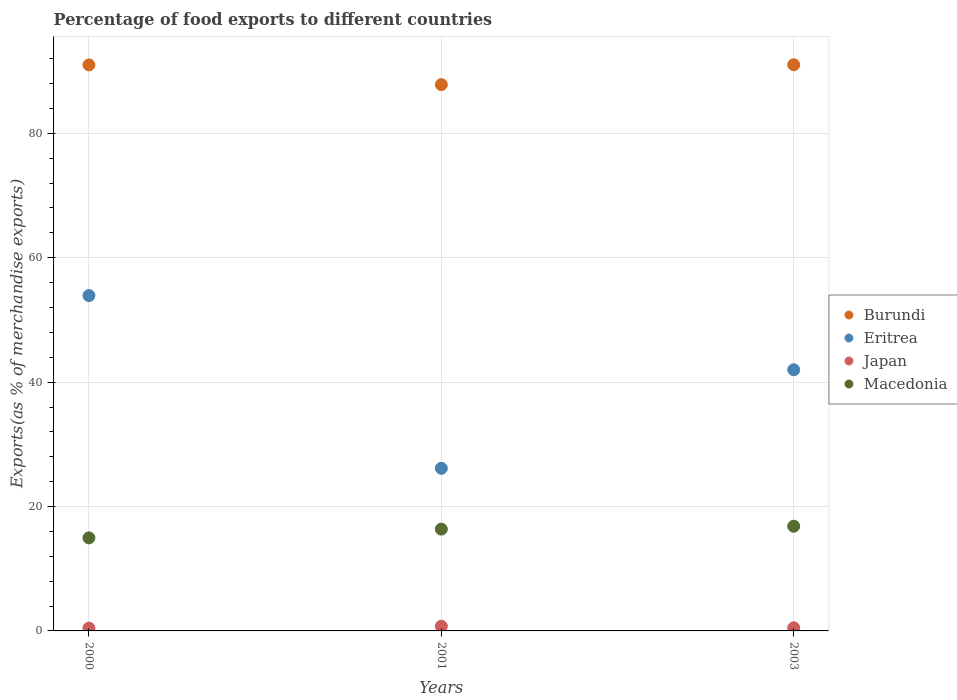What is the percentage of exports to different countries in Burundi in 2001?
Ensure brevity in your answer.  87.83. Across all years, what is the maximum percentage of exports to different countries in Burundi?
Give a very brief answer. 91.03. Across all years, what is the minimum percentage of exports to different countries in Japan?
Provide a succinct answer. 0.45. In which year was the percentage of exports to different countries in Burundi maximum?
Your answer should be very brief. 2003. What is the total percentage of exports to different countries in Macedonia in the graph?
Keep it short and to the point. 48.16. What is the difference between the percentage of exports to different countries in Japan in 2000 and that in 2003?
Keep it short and to the point. -0.05. What is the difference between the percentage of exports to different countries in Burundi in 2001 and the percentage of exports to different countries in Macedonia in 2000?
Offer a terse response. 72.87. What is the average percentage of exports to different countries in Burundi per year?
Your response must be concise. 89.95. In the year 2001, what is the difference between the percentage of exports to different countries in Eritrea and percentage of exports to different countries in Burundi?
Provide a short and direct response. -61.68. What is the ratio of the percentage of exports to different countries in Japan in 2001 to that in 2003?
Keep it short and to the point. 1.51. What is the difference between the highest and the second highest percentage of exports to different countries in Macedonia?
Ensure brevity in your answer.  0.46. What is the difference between the highest and the lowest percentage of exports to different countries in Japan?
Ensure brevity in your answer.  0.31. In how many years, is the percentage of exports to different countries in Eritrea greater than the average percentage of exports to different countries in Eritrea taken over all years?
Provide a succinct answer. 2. Is it the case that in every year, the sum of the percentage of exports to different countries in Burundi and percentage of exports to different countries in Japan  is greater than the sum of percentage of exports to different countries in Eritrea and percentage of exports to different countries in Macedonia?
Ensure brevity in your answer.  No. Is it the case that in every year, the sum of the percentage of exports to different countries in Japan and percentage of exports to different countries in Eritrea  is greater than the percentage of exports to different countries in Burundi?
Make the answer very short. No. Is the percentage of exports to different countries in Eritrea strictly greater than the percentage of exports to different countries in Japan over the years?
Give a very brief answer. Yes. How many dotlines are there?
Keep it short and to the point. 4. How many years are there in the graph?
Your answer should be compact. 3. Are the values on the major ticks of Y-axis written in scientific E-notation?
Ensure brevity in your answer.  No. Does the graph contain any zero values?
Make the answer very short. No. Where does the legend appear in the graph?
Offer a terse response. Center right. What is the title of the graph?
Your answer should be very brief. Percentage of food exports to different countries. What is the label or title of the Y-axis?
Provide a short and direct response. Exports(as % of merchandise exports). What is the Exports(as % of merchandise exports) of Burundi in 2000?
Your answer should be compact. 91. What is the Exports(as % of merchandise exports) in Eritrea in 2000?
Offer a very short reply. 53.91. What is the Exports(as % of merchandise exports) of Japan in 2000?
Ensure brevity in your answer.  0.45. What is the Exports(as % of merchandise exports) of Macedonia in 2000?
Offer a very short reply. 14.96. What is the Exports(as % of merchandise exports) in Burundi in 2001?
Provide a short and direct response. 87.83. What is the Exports(as % of merchandise exports) of Eritrea in 2001?
Give a very brief answer. 26.15. What is the Exports(as % of merchandise exports) in Japan in 2001?
Keep it short and to the point. 0.76. What is the Exports(as % of merchandise exports) in Macedonia in 2001?
Give a very brief answer. 16.37. What is the Exports(as % of merchandise exports) of Burundi in 2003?
Offer a terse response. 91.03. What is the Exports(as % of merchandise exports) in Eritrea in 2003?
Provide a short and direct response. 41.99. What is the Exports(as % of merchandise exports) of Japan in 2003?
Make the answer very short. 0.5. What is the Exports(as % of merchandise exports) in Macedonia in 2003?
Your answer should be very brief. 16.83. Across all years, what is the maximum Exports(as % of merchandise exports) in Burundi?
Ensure brevity in your answer.  91.03. Across all years, what is the maximum Exports(as % of merchandise exports) of Eritrea?
Your answer should be compact. 53.91. Across all years, what is the maximum Exports(as % of merchandise exports) in Japan?
Make the answer very short. 0.76. Across all years, what is the maximum Exports(as % of merchandise exports) of Macedonia?
Offer a very short reply. 16.83. Across all years, what is the minimum Exports(as % of merchandise exports) in Burundi?
Your answer should be very brief. 87.83. Across all years, what is the minimum Exports(as % of merchandise exports) in Eritrea?
Provide a succinct answer. 26.15. Across all years, what is the minimum Exports(as % of merchandise exports) in Japan?
Provide a short and direct response. 0.45. Across all years, what is the minimum Exports(as % of merchandise exports) of Macedonia?
Keep it short and to the point. 14.96. What is the total Exports(as % of merchandise exports) in Burundi in the graph?
Your response must be concise. 269.86. What is the total Exports(as % of merchandise exports) of Eritrea in the graph?
Offer a very short reply. 122.05. What is the total Exports(as % of merchandise exports) in Japan in the graph?
Offer a very short reply. 1.72. What is the total Exports(as % of merchandise exports) of Macedonia in the graph?
Your answer should be compact. 48.16. What is the difference between the Exports(as % of merchandise exports) of Burundi in 2000 and that in 2001?
Keep it short and to the point. 3.17. What is the difference between the Exports(as % of merchandise exports) of Eritrea in 2000 and that in 2001?
Ensure brevity in your answer.  27.77. What is the difference between the Exports(as % of merchandise exports) of Japan in 2000 and that in 2001?
Your answer should be compact. -0.31. What is the difference between the Exports(as % of merchandise exports) in Macedonia in 2000 and that in 2001?
Your response must be concise. -1.41. What is the difference between the Exports(as % of merchandise exports) in Burundi in 2000 and that in 2003?
Provide a succinct answer. -0.03. What is the difference between the Exports(as % of merchandise exports) in Eritrea in 2000 and that in 2003?
Offer a terse response. 11.93. What is the difference between the Exports(as % of merchandise exports) in Japan in 2000 and that in 2003?
Your answer should be compact. -0.05. What is the difference between the Exports(as % of merchandise exports) of Macedonia in 2000 and that in 2003?
Give a very brief answer. -1.87. What is the difference between the Exports(as % of merchandise exports) of Burundi in 2001 and that in 2003?
Offer a very short reply. -3.2. What is the difference between the Exports(as % of merchandise exports) in Eritrea in 2001 and that in 2003?
Provide a short and direct response. -15.84. What is the difference between the Exports(as % of merchandise exports) of Japan in 2001 and that in 2003?
Your response must be concise. 0.26. What is the difference between the Exports(as % of merchandise exports) of Macedonia in 2001 and that in 2003?
Make the answer very short. -0.46. What is the difference between the Exports(as % of merchandise exports) in Burundi in 2000 and the Exports(as % of merchandise exports) in Eritrea in 2001?
Offer a terse response. 64.86. What is the difference between the Exports(as % of merchandise exports) in Burundi in 2000 and the Exports(as % of merchandise exports) in Japan in 2001?
Your answer should be very brief. 90.24. What is the difference between the Exports(as % of merchandise exports) in Burundi in 2000 and the Exports(as % of merchandise exports) in Macedonia in 2001?
Your answer should be very brief. 74.63. What is the difference between the Exports(as % of merchandise exports) of Eritrea in 2000 and the Exports(as % of merchandise exports) of Japan in 2001?
Keep it short and to the point. 53.16. What is the difference between the Exports(as % of merchandise exports) in Eritrea in 2000 and the Exports(as % of merchandise exports) in Macedonia in 2001?
Your answer should be compact. 37.55. What is the difference between the Exports(as % of merchandise exports) in Japan in 2000 and the Exports(as % of merchandise exports) in Macedonia in 2001?
Give a very brief answer. -15.91. What is the difference between the Exports(as % of merchandise exports) of Burundi in 2000 and the Exports(as % of merchandise exports) of Eritrea in 2003?
Your answer should be very brief. 49.01. What is the difference between the Exports(as % of merchandise exports) of Burundi in 2000 and the Exports(as % of merchandise exports) of Japan in 2003?
Give a very brief answer. 90.5. What is the difference between the Exports(as % of merchandise exports) of Burundi in 2000 and the Exports(as % of merchandise exports) of Macedonia in 2003?
Your response must be concise. 74.17. What is the difference between the Exports(as % of merchandise exports) in Eritrea in 2000 and the Exports(as % of merchandise exports) in Japan in 2003?
Your response must be concise. 53.41. What is the difference between the Exports(as % of merchandise exports) in Eritrea in 2000 and the Exports(as % of merchandise exports) in Macedonia in 2003?
Make the answer very short. 37.08. What is the difference between the Exports(as % of merchandise exports) of Japan in 2000 and the Exports(as % of merchandise exports) of Macedonia in 2003?
Keep it short and to the point. -16.38. What is the difference between the Exports(as % of merchandise exports) in Burundi in 2001 and the Exports(as % of merchandise exports) in Eritrea in 2003?
Your answer should be compact. 45.84. What is the difference between the Exports(as % of merchandise exports) of Burundi in 2001 and the Exports(as % of merchandise exports) of Japan in 2003?
Provide a short and direct response. 87.33. What is the difference between the Exports(as % of merchandise exports) of Burundi in 2001 and the Exports(as % of merchandise exports) of Macedonia in 2003?
Your answer should be compact. 71. What is the difference between the Exports(as % of merchandise exports) of Eritrea in 2001 and the Exports(as % of merchandise exports) of Japan in 2003?
Give a very brief answer. 25.64. What is the difference between the Exports(as % of merchandise exports) of Eritrea in 2001 and the Exports(as % of merchandise exports) of Macedonia in 2003?
Make the answer very short. 9.32. What is the difference between the Exports(as % of merchandise exports) of Japan in 2001 and the Exports(as % of merchandise exports) of Macedonia in 2003?
Keep it short and to the point. -16.07. What is the average Exports(as % of merchandise exports) of Burundi per year?
Your answer should be compact. 89.95. What is the average Exports(as % of merchandise exports) in Eritrea per year?
Give a very brief answer. 40.68. What is the average Exports(as % of merchandise exports) in Japan per year?
Give a very brief answer. 0.57. What is the average Exports(as % of merchandise exports) of Macedonia per year?
Your response must be concise. 16.05. In the year 2000, what is the difference between the Exports(as % of merchandise exports) in Burundi and Exports(as % of merchandise exports) in Eritrea?
Keep it short and to the point. 37.09. In the year 2000, what is the difference between the Exports(as % of merchandise exports) of Burundi and Exports(as % of merchandise exports) of Japan?
Provide a short and direct response. 90.55. In the year 2000, what is the difference between the Exports(as % of merchandise exports) in Burundi and Exports(as % of merchandise exports) in Macedonia?
Provide a short and direct response. 76.04. In the year 2000, what is the difference between the Exports(as % of merchandise exports) of Eritrea and Exports(as % of merchandise exports) of Japan?
Provide a succinct answer. 53.46. In the year 2000, what is the difference between the Exports(as % of merchandise exports) in Eritrea and Exports(as % of merchandise exports) in Macedonia?
Your answer should be very brief. 38.96. In the year 2000, what is the difference between the Exports(as % of merchandise exports) of Japan and Exports(as % of merchandise exports) of Macedonia?
Provide a short and direct response. -14.51. In the year 2001, what is the difference between the Exports(as % of merchandise exports) of Burundi and Exports(as % of merchandise exports) of Eritrea?
Your answer should be very brief. 61.68. In the year 2001, what is the difference between the Exports(as % of merchandise exports) in Burundi and Exports(as % of merchandise exports) in Japan?
Your answer should be very brief. 87.07. In the year 2001, what is the difference between the Exports(as % of merchandise exports) of Burundi and Exports(as % of merchandise exports) of Macedonia?
Your answer should be very brief. 71.46. In the year 2001, what is the difference between the Exports(as % of merchandise exports) of Eritrea and Exports(as % of merchandise exports) of Japan?
Provide a short and direct response. 25.39. In the year 2001, what is the difference between the Exports(as % of merchandise exports) in Eritrea and Exports(as % of merchandise exports) in Macedonia?
Your answer should be very brief. 9.78. In the year 2001, what is the difference between the Exports(as % of merchandise exports) in Japan and Exports(as % of merchandise exports) in Macedonia?
Provide a short and direct response. -15.61. In the year 2003, what is the difference between the Exports(as % of merchandise exports) of Burundi and Exports(as % of merchandise exports) of Eritrea?
Provide a succinct answer. 49.04. In the year 2003, what is the difference between the Exports(as % of merchandise exports) in Burundi and Exports(as % of merchandise exports) in Japan?
Offer a terse response. 90.52. In the year 2003, what is the difference between the Exports(as % of merchandise exports) in Burundi and Exports(as % of merchandise exports) in Macedonia?
Your answer should be very brief. 74.2. In the year 2003, what is the difference between the Exports(as % of merchandise exports) of Eritrea and Exports(as % of merchandise exports) of Japan?
Give a very brief answer. 41.48. In the year 2003, what is the difference between the Exports(as % of merchandise exports) in Eritrea and Exports(as % of merchandise exports) in Macedonia?
Your response must be concise. 25.16. In the year 2003, what is the difference between the Exports(as % of merchandise exports) of Japan and Exports(as % of merchandise exports) of Macedonia?
Ensure brevity in your answer.  -16.33. What is the ratio of the Exports(as % of merchandise exports) in Burundi in 2000 to that in 2001?
Your answer should be very brief. 1.04. What is the ratio of the Exports(as % of merchandise exports) of Eritrea in 2000 to that in 2001?
Offer a very short reply. 2.06. What is the ratio of the Exports(as % of merchandise exports) of Japan in 2000 to that in 2001?
Provide a succinct answer. 0.6. What is the ratio of the Exports(as % of merchandise exports) of Macedonia in 2000 to that in 2001?
Make the answer very short. 0.91. What is the ratio of the Exports(as % of merchandise exports) in Burundi in 2000 to that in 2003?
Provide a short and direct response. 1. What is the ratio of the Exports(as % of merchandise exports) in Eritrea in 2000 to that in 2003?
Make the answer very short. 1.28. What is the ratio of the Exports(as % of merchandise exports) in Japan in 2000 to that in 2003?
Provide a succinct answer. 0.9. What is the ratio of the Exports(as % of merchandise exports) in Macedonia in 2000 to that in 2003?
Offer a terse response. 0.89. What is the ratio of the Exports(as % of merchandise exports) in Burundi in 2001 to that in 2003?
Your response must be concise. 0.96. What is the ratio of the Exports(as % of merchandise exports) in Eritrea in 2001 to that in 2003?
Keep it short and to the point. 0.62. What is the ratio of the Exports(as % of merchandise exports) in Japan in 2001 to that in 2003?
Make the answer very short. 1.51. What is the ratio of the Exports(as % of merchandise exports) in Macedonia in 2001 to that in 2003?
Keep it short and to the point. 0.97. What is the difference between the highest and the second highest Exports(as % of merchandise exports) in Burundi?
Give a very brief answer. 0.03. What is the difference between the highest and the second highest Exports(as % of merchandise exports) in Eritrea?
Ensure brevity in your answer.  11.93. What is the difference between the highest and the second highest Exports(as % of merchandise exports) of Japan?
Make the answer very short. 0.26. What is the difference between the highest and the second highest Exports(as % of merchandise exports) in Macedonia?
Provide a succinct answer. 0.46. What is the difference between the highest and the lowest Exports(as % of merchandise exports) of Burundi?
Your response must be concise. 3.2. What is the difference between the highest and the lowest Exports(as % of merchandise exports) in Eritrea?
Provide a succinct answer. 27.77. What is the difference between the highest and the lowest Exports(as % of merchandise exports) of Japan?
Give a very brief answer. 0.31. What is the difference between the highest and the lowest Exports(as % of merchandise exports) in Macedonia?
Give a very brief answer. 1.87. 